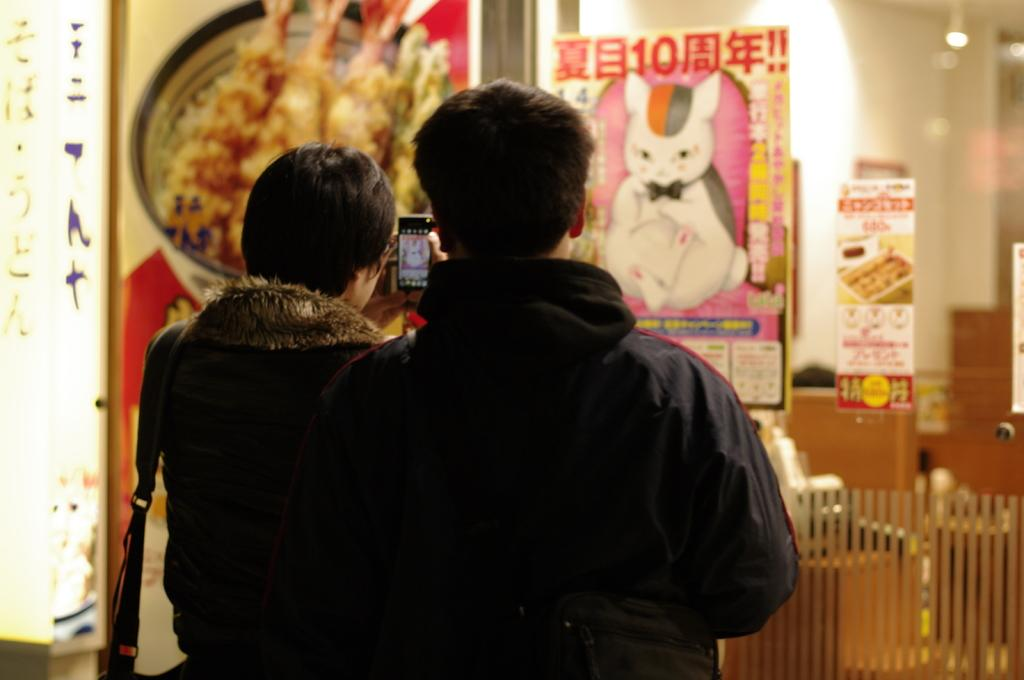How many people are in the image? There are two people in the image. What is one person doing in the image? One person is holding a phone. What can be seen on the walls in the image? There are posters on the walls. Are the two people in the image sisters? There is no information provided about the relationship between the two people in the image, so we cannot determine if they are sisters. 